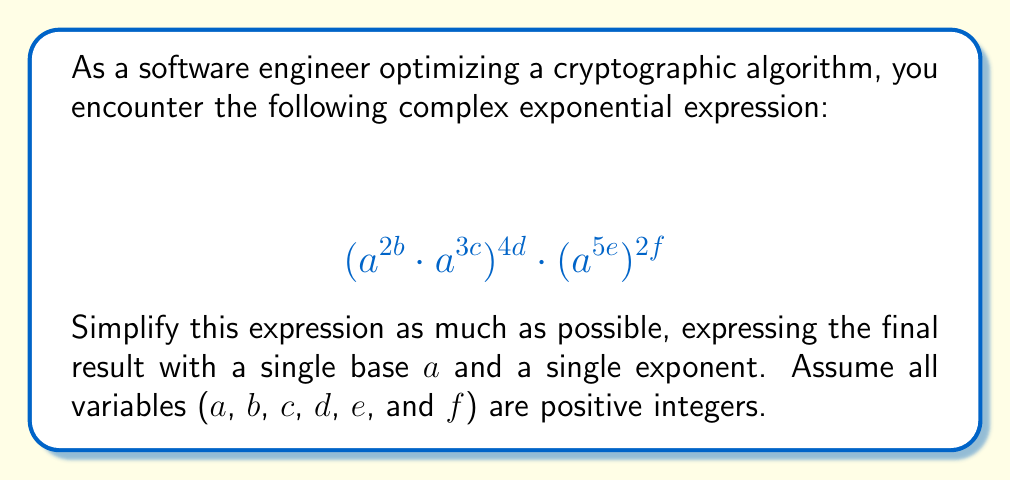Teach me how to tackle this problem. Let's break this down step-by-step:

1) First, let's focus on the left part: $(a^{2b} \cdot a^{3c})^{4d}$
   
   When multiplying exponential terms with the same base, we add the exponents:
   $$(a^{2b} \cdot a^{3c})^{4d} = (a^{2b+3c})^{4d}$$

2) When raising an exponential term to a power, we multiply the exponents:
   $$(a^{2b+3c})^{4d} = a^{(2b+3c)4d} = a^{8bd+12cd}$$

3) Now, let's simplify the right part: $(a^{5e})^{2f}$
   
   Again, when raising an exponential term to a power, we multiply the exponents:
   $$(a^{5e})^{2f} = a^{5e \cdot 2f} = a^{10ef}$$

4) Now our expression looks like this:
   $$a^{8bd+12cd} \cdot a^{10ef}$$

5) When multiplying exponential terms with the same base, we add the exponents:
   $$a^{8bd+12cd+10ef}$$

This is our final simplified form, with a single base $a$ and a single exponent that combines all the variables.
Answer: $$a^{8bd+12cd+10ef}$$ 